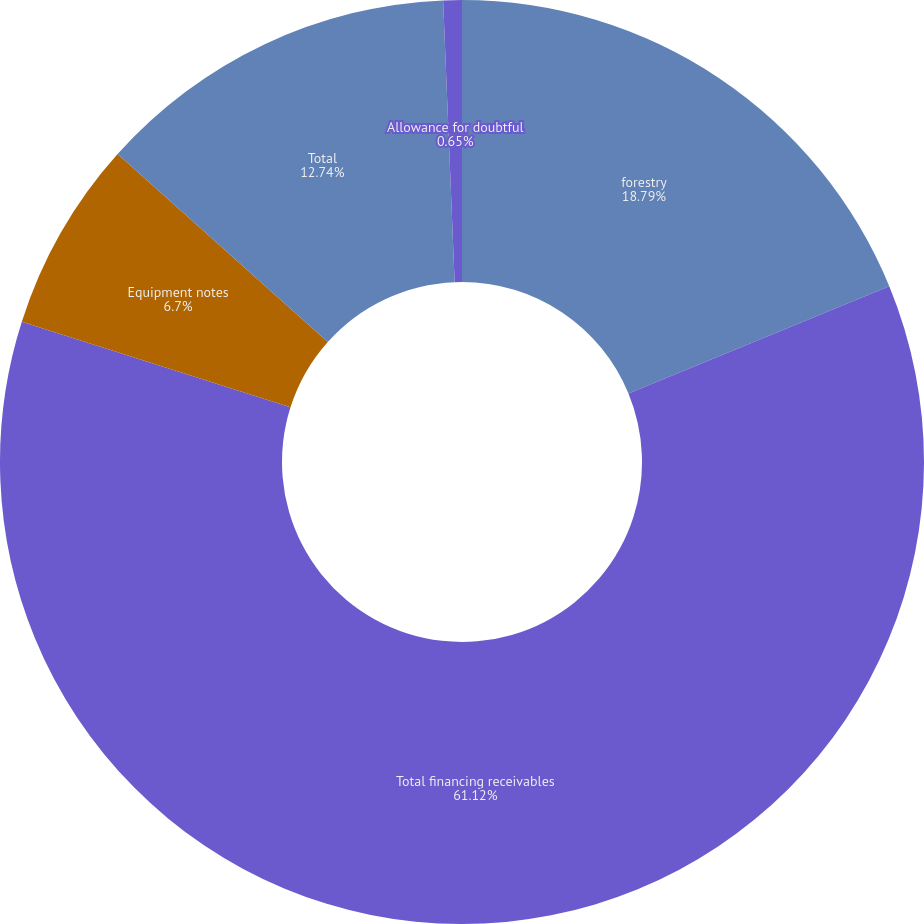Convert chart to OTSL. <chart><loc_0><loc_0><loc_500><loc_500><pie_chart><fcel>forestry<fcel>Total financing receivables<fcel>Equipment notes<fcel>Total<fcel>Allowance for doubtful<nl><fcel>18.79%<fcel>61.12%<fcel>6.7%<fcel>12.74%<fcel>0.65%<nl></chart> 